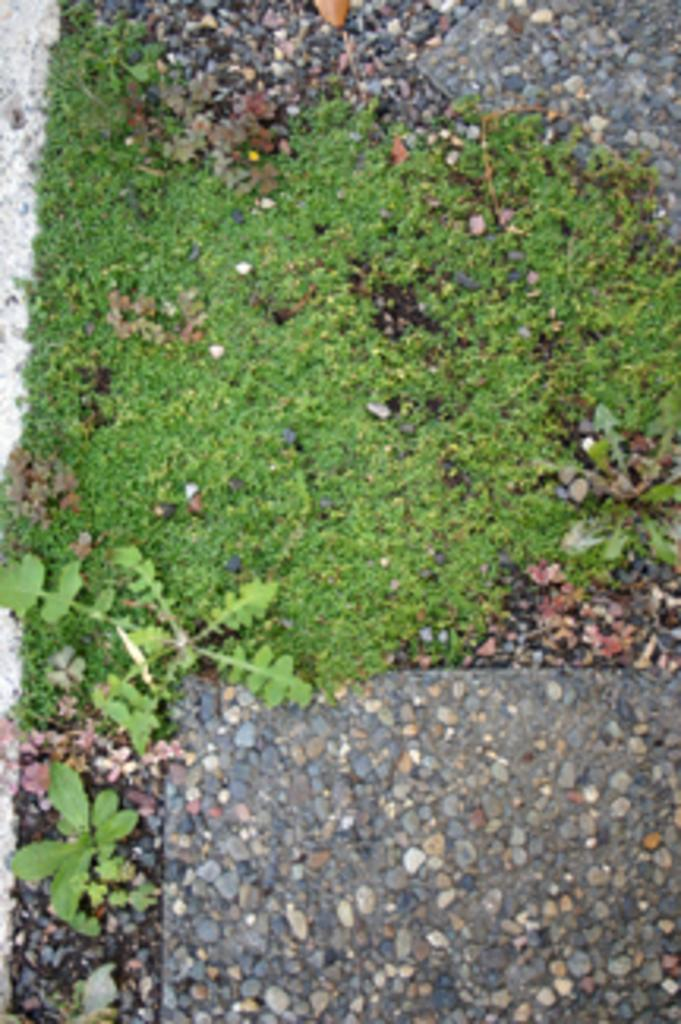What type of living organisms can be seen in the image? There are plants in the image. What might be present at the bottom of the image? There might be grass at the bottom of the image. What type of inanimate objects are visible in the image? There are stones in the image. Are there any objects placed on the stones? There might be glasses on the stones. How many chickens can be seen interacting with the furniture in the image? There are no chickens or furniture present in the image. What type of blade is being used to cut the grass in the image? There is no blade visible in the image, and the grass is not being cut. 